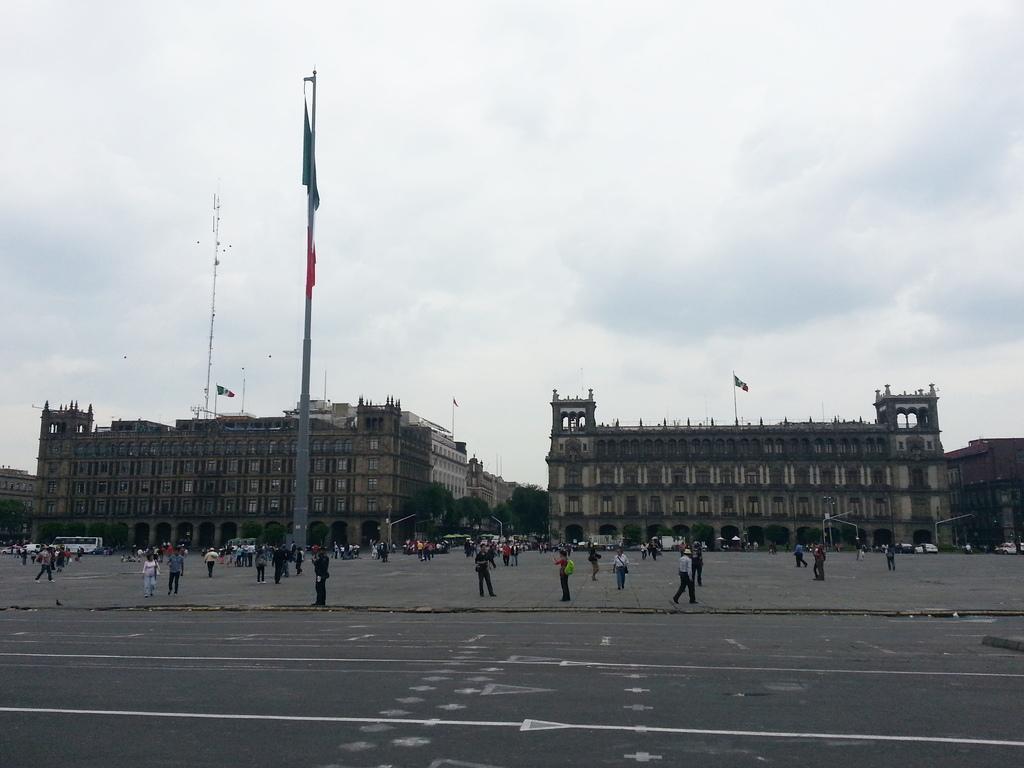Please provide a concise description of this image. In the picture we can see a road and behind it, we can see a space with many people are walking and standing and far away from it, we can see two buildings and between the buildings we can see road with some trees near it and poles and behind the buildings we can see a sky with clouds. 